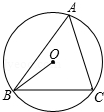Tell me what you observe in the image. The diagram depicts a circle labeled as circle O, centered at point O. Inside the circle, there are two secant lines that intersect at a point on the circumference, forming an angle labeled A at the intersection. A radial line extends from point O to point B on the circumference, and another line connects point O to point C, also on the circumference. The angle formed between these two lines at point O is labeled as OBC. This configuration might suggest various geometric properties such as angle measurements and their relationships, pertinent to circle and angle theorems. 